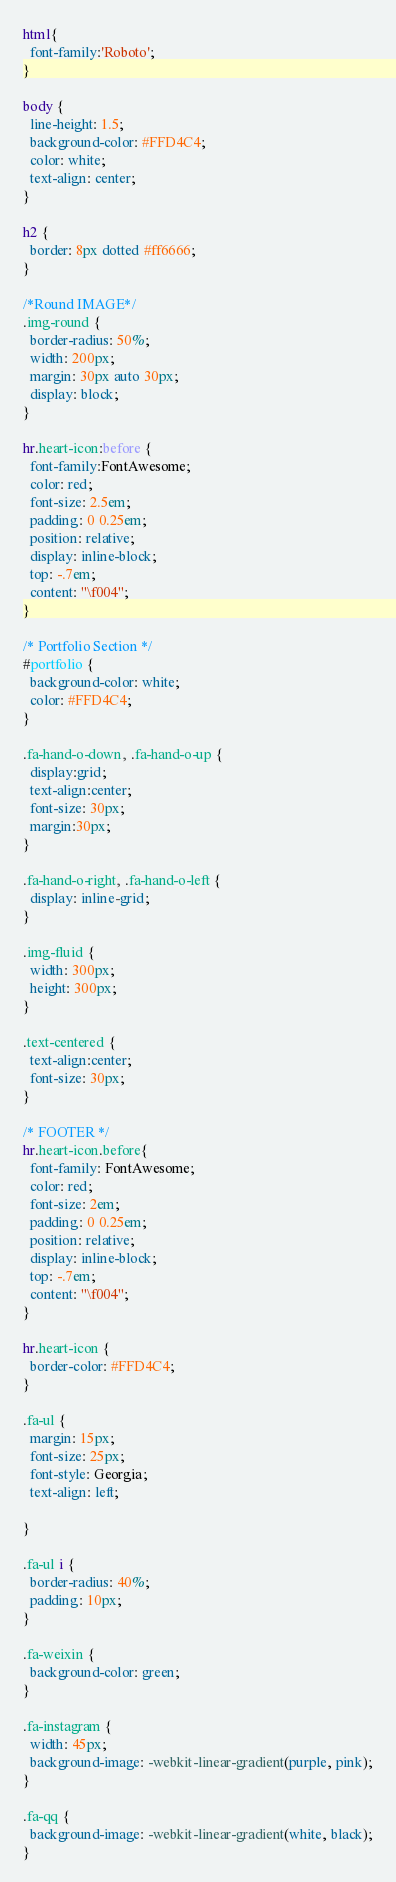Convert code to text. <code><loc_0><loc_0><loc_500><loc_500><_CSS_>html{
  font-family:'Roboto';
}

body {
  line-height: 1.5;
  background-color: #FFD4C4;
  color: white;
  text-align: center;
}

h2 {
  border: 8px dotted #ff6666;
}

/*Round IMAGE*/
.img-round {
  border-radius: 50%;
  width: 200px;
  margin: 30px auto 30px;
  display: block;
}

hr.heart-icon:before {
  font-family:FontAwesome;
  color: red;
  font-size: 2.5em;
  padding: 0 0.25em;
  position: relative;
  display: inline-block;
  top: -.7em;
  content: "\f004";
}

/* Portfolio Section */
#portfolio {
  background-color: white;
  color: #FFD4C4;
}

.fa-hand-o-down, .fa-hand-o-up {
  display:grid;
  text-align:center;
  font-size: 30px;
  margin:30px;
}

.fa-hand-o-right, .fa-hand-o-left {
  display: inline-grid;
}

.img-fluid {
  width: 300px;
  height: 300px;
}

.text-centered {
  text-align:center;
  font-size: 30px;
}

/* FOOTER */
hr.heart-icon.before{
  font-family: FontAwesome;
  color: red;
  font-size: 2em;
  padding: 0 0.25em;
  position: relative;
  display: inline-block;
  top: -.7em;
  content: "\f004";
}

hr.heart-icon {
  border-color: #FFD4C4;
}

.fa-ul {
  margin: 15px;
  font-size: 25px;
  font-style: Georgia;
  text-align: left;

}

.fa-ul i {
  border-radius: 40%;
  padding: 10px;
}

.fa-weixin {
  background-color: green;
}

.fa-instagram {
  width: 45px;
  background-image: -webkit-linear-gradient(purple, pink);
}

.fa-qq {
  background-image: -webkit-linear-gradient(white, black);
}
</code> 